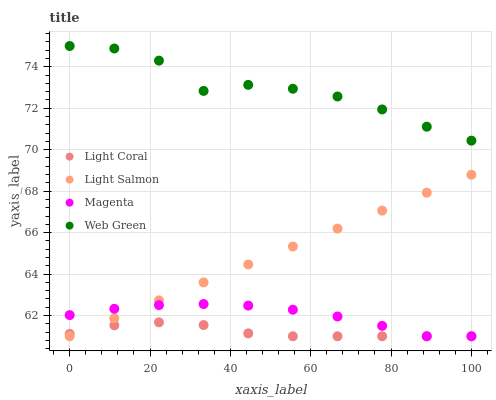Does Light Coral have the minimum area under the curve?
Answer yes or no. Yes. Does Web Green have the maximum area under the curve?
Answer yes or no. Yes. Does Light Salmon have the minimum area under the curve?
Answer yes or no. No. Does Light Salmon have the maximum area under the curve?
Answer yes or no. No. Is Light Salmon the smoothest?
Answer yes or no. Yes. Is Web Green the roughest?
Answer yes or no. Yes. Is Magenta the smoothest?
Answer yes or no. No. Is Magenta the roughest?
Answer yes or no. No. Does Light Coral have the lowest value?
Answer yes or no. Yes. Does Web Green have the lowest value?
Answer yes or no. No. Does Web Green have the highest value?
Answer yes or no. Yes. Does Light Salmon have the highest value?
Answer yes or no. No. Is Light Coral less than Web Green?
Answer yes or no. Yes. Is Web Green greater than Magenta?
Answer yes or no. Yes. Does Light Salmon intersect Magenta?
Answer yes or no. Yes. Is Light Salmon less than Magenta?
Answer yes or no. No. Is Light Salmon greater than Magenta?
Answer yes or no. No. Does Light Coral intersect Web Green?
Answer yes or no. No. 